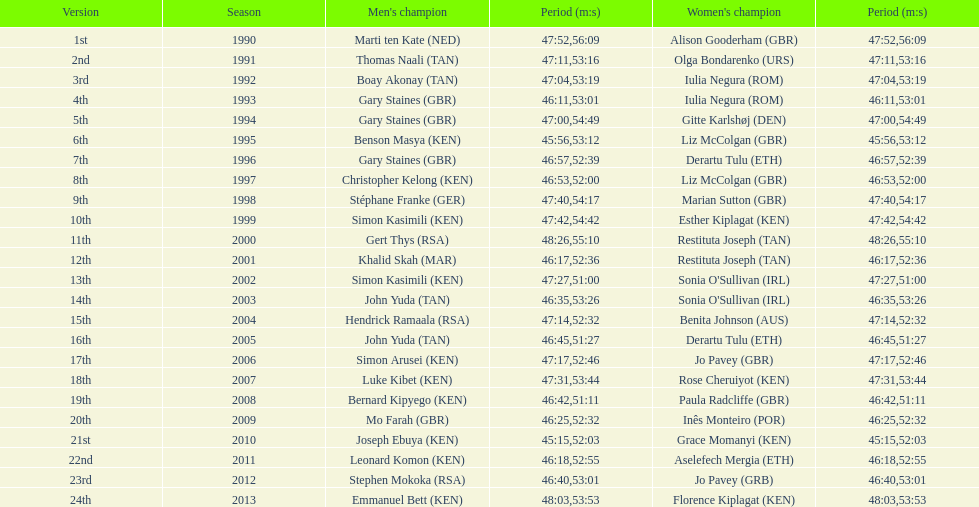What is the title of the initial female victor? Alison Gooderham. 